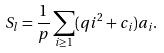<formula> <loc_0><loc_0><loc_500><loc_500>S _ { l } = \frac { 1 } { p } \sum _ { i \geq 1 } ( q i ^ { 2 } + c _ { i } ) a _ { i } .</formula> 